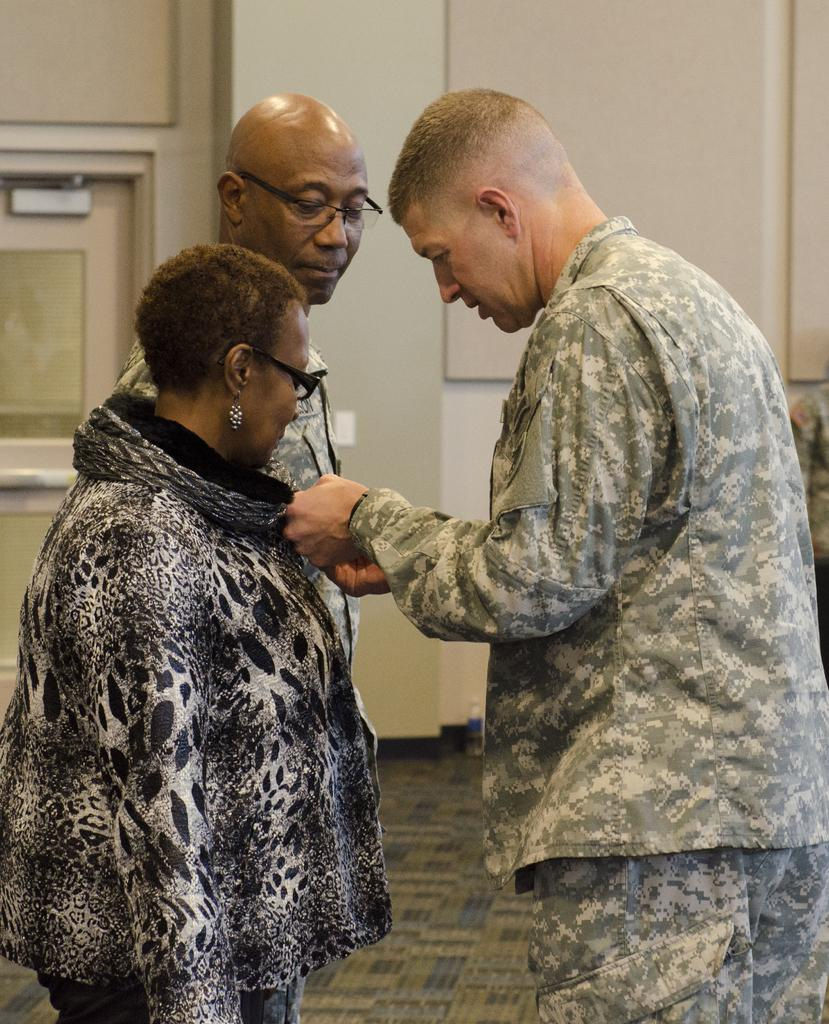How many people are in the image? There are three persons in the image. Can you describe any specific features of the people in the image? Two of the persons are wearing spectacles. What type of tax is being discussed by the persons in the image? There is no indication in the image that the persons are discussing any type of tax. 